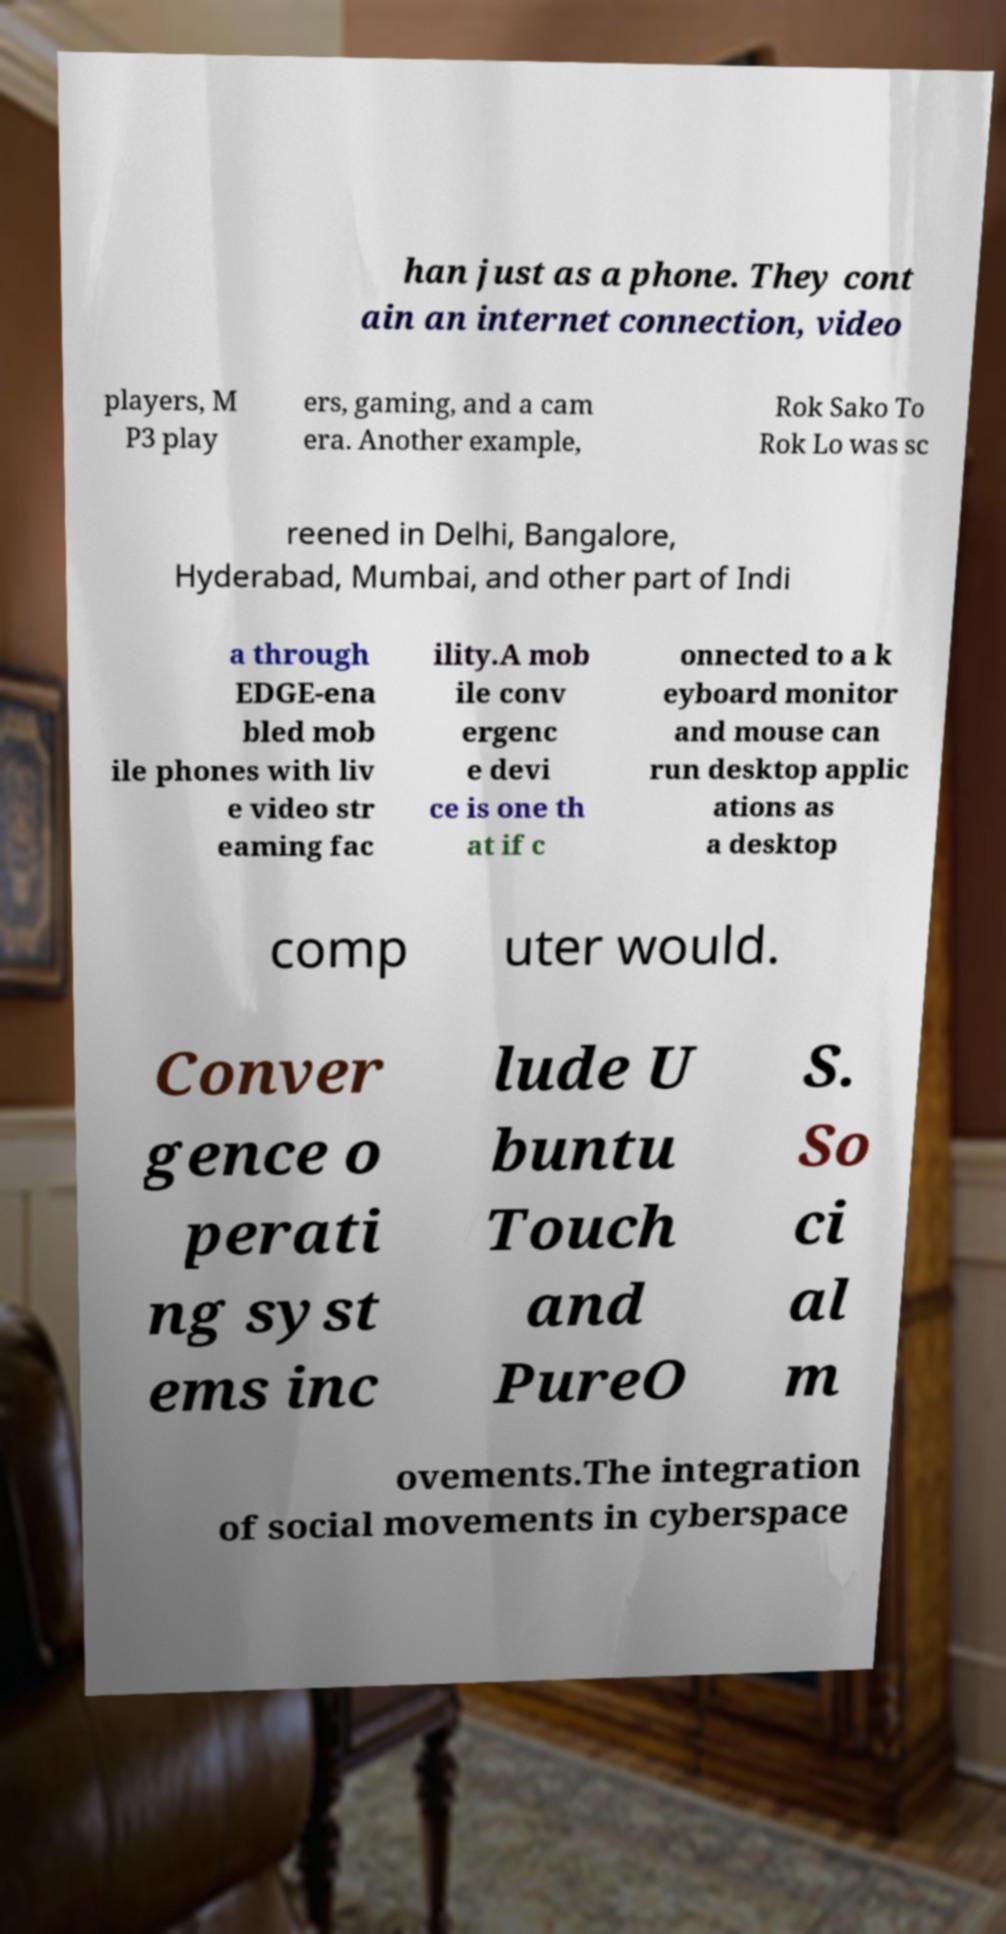Please read and relay the text visible in this image. What does it say? han just as a phone. They cont ain an internet connection, video players, M P3 play ers, gaming, and a cam era. Another example, Rok Sako To Rok Lo was sc reened in Delhi, Bangalore, Hyderabad, Mumbai, and other part of Indi a through EDGE-ena bled mob ile phones with liv e video str eaming fac ility.A mob ile conv ergenc e devi ce is one th at if c onnected to a k eyboard monitor and mouse can run desktop applic ations as a desktop comp uter would. Conver gence o perati ng syst ems inc lude U buntu Touch and PureO S. So ci al m ovements.The integration of social movements in cyberspace 